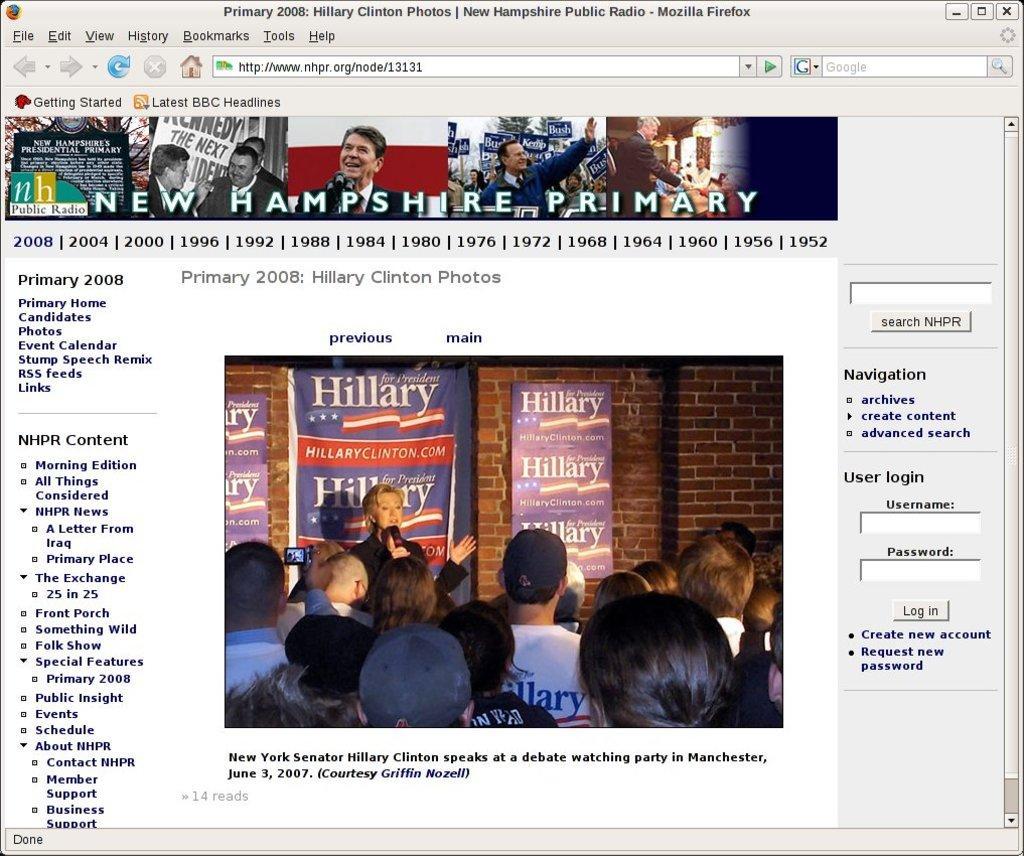Please provide a concise description of this image. Here we can see web page,on this page we can see people and information. 